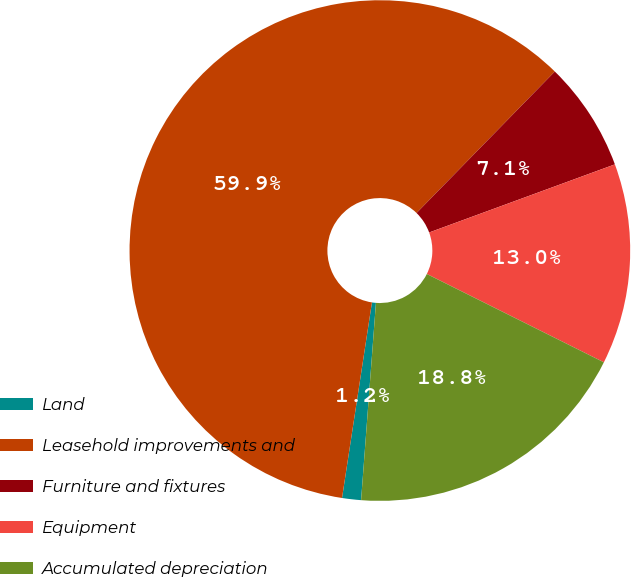Convert chart. <chart><loc_0><loc_0><loc_500><loc_500><pie_chart><fcel>Land<fcel>Leasehold improvements and<fcel>Furniture and fixtures<fcel>Equipment<fcel>Accumulated depreciation<nl><fcel>1.22%<fcel>59.9%<fcel>7.09%<fcel>12.96%<fcel>18.83%<nl></chart> 